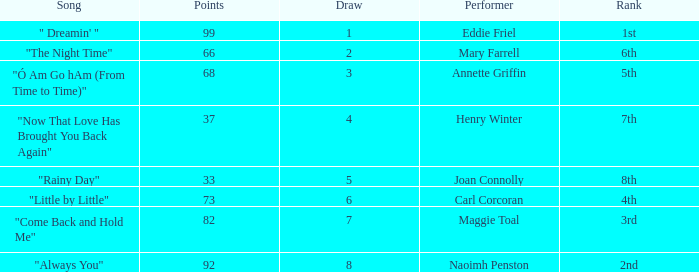What is the average number of points when the ranking is 7th and the draw is less than 4? None. Would you mind parsing the complete table? {'header': ['Song', 'Points', 'Draw', 'Performer', 'Rank'], 'rows': [['" Dreamin\' "', '99', '1', 'Eddie Friel', '1st'], ['"The Night Time"', '66', '2', 'Mary Farrell', '6th'], ['"Ó Am Go hAm (From Time to Time)"', '68', '3', 'Annette Griffin', '5th'], ['"Now That Love Has Brought You Back Again"', '37', '4', 'Henry Winter', '7th'], ['"Rainy Day"', '33', '5', 'Joan Connolly', '8th'], ['"Little by Little"', '73', '6', 'Carl Corcoran', '4th'], ['"Come Back and Hold Me"', '82', '7', 'Maggie Toal', '3rd'], ['"Always You"', '92', '8', 'Naoimh Penston', '2nd']]} 